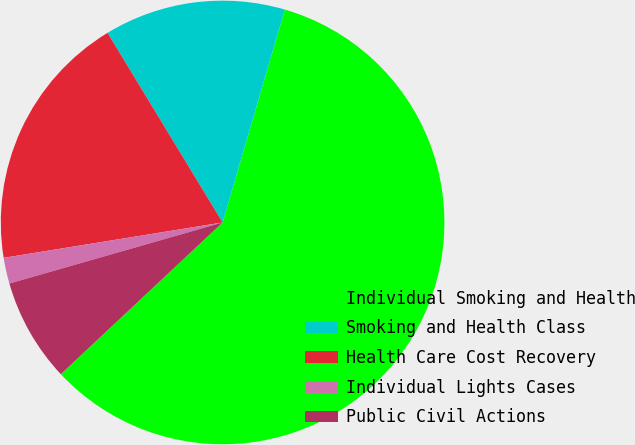Convert chart to OTSL. <chart><loc_0><loc_0><loc_500><loc_500><pie_chart><fcel>Individual Smoking and Health<fcel>Smoking and Health Class<fcel>Health Care Cost Recovery<fcel>Individual Lights Cases<fcel>Public Civil Actions<nl><fcel>58.49%<fcel>13.21%<fcel>18.87%<fcel>1.89%<fcel>7.55%<nl></chart> 